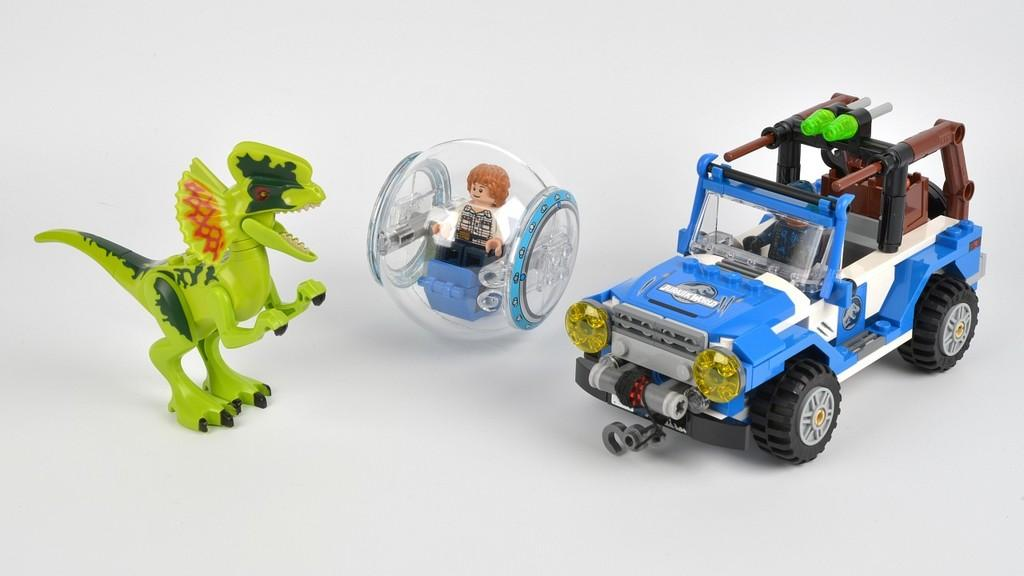What objects are present in the image? There are toys in the image. What is the color of the surface on which the toys are placed? The toys are on a white surface. Where is the queen sitting in the image? There is no queen present in the image; it only features toys on a white surface. 